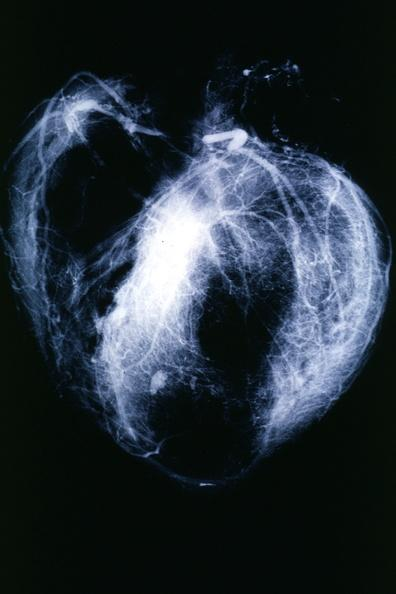does angiogram show postmortangiogram with apparent lesions in proximal right coronary?
Answer the question using a single word or phrase. No 